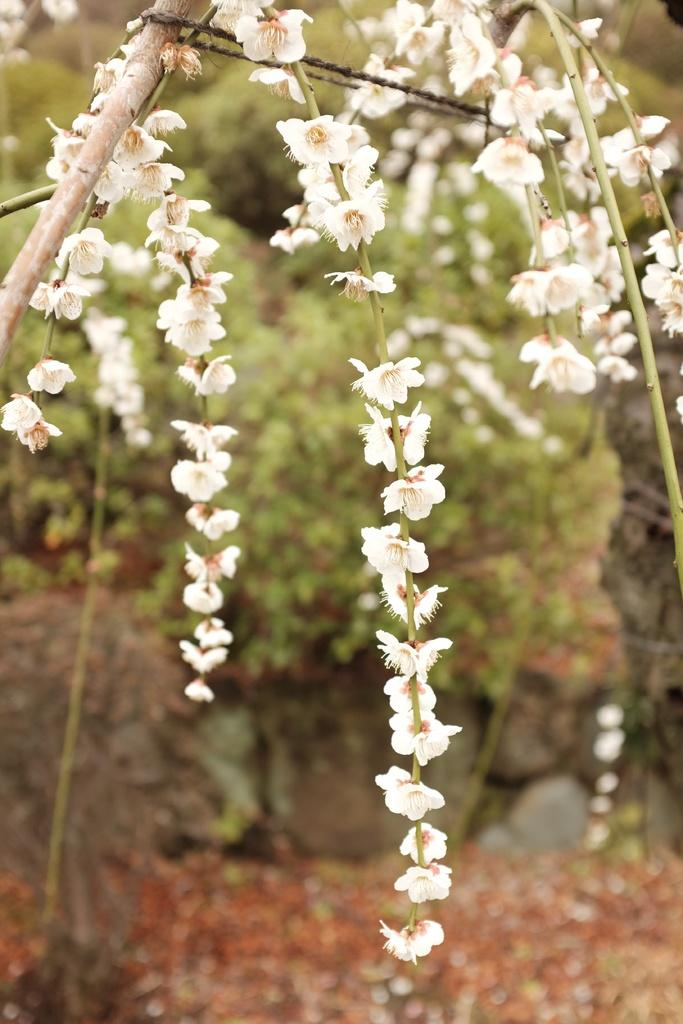What type of flowers are in the middle of the picture? There are white color flowers in the middle of the picture. What can be seen in the background of the picture? There are trees in the background of the picture. How does the pollution affect the flowers in the image? There is no indication of pollution in the image, so it cannot be determined how it might affect the flowers. 